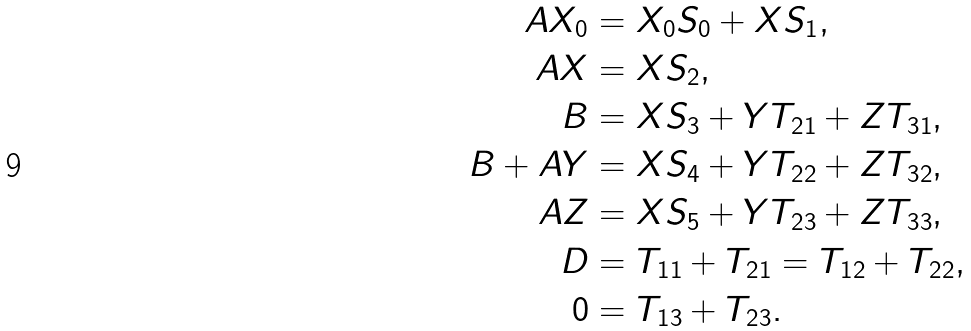<formula> <loc_0><loc_0><loc_500><loc_500>A X _ { 0 } & = X _ { 0 } S _ { 0 } + X S _ { 1 } , \\ A X & = X S _ { 2 } , \\ B & = X S _ { 3 } + Y T _ { 2 1 } + Z T _ { 3 1 } , \\ B + A Y & = X S _ { 4 } + Y T _ { 2 2 } + Z T _ { 3 2 } , \\ A Z & = X S _ { 5 } + Y T _ { 2 3 } + Z T _ { 3 3 } , \\ D & = T _ { 1 1 } + T _ { 2 1 } = T _ { 1 2 } + T _ { 2 2 } , \\ 0 & = T _ { 1 3 } + T _ { 2 3 } .</formula> 